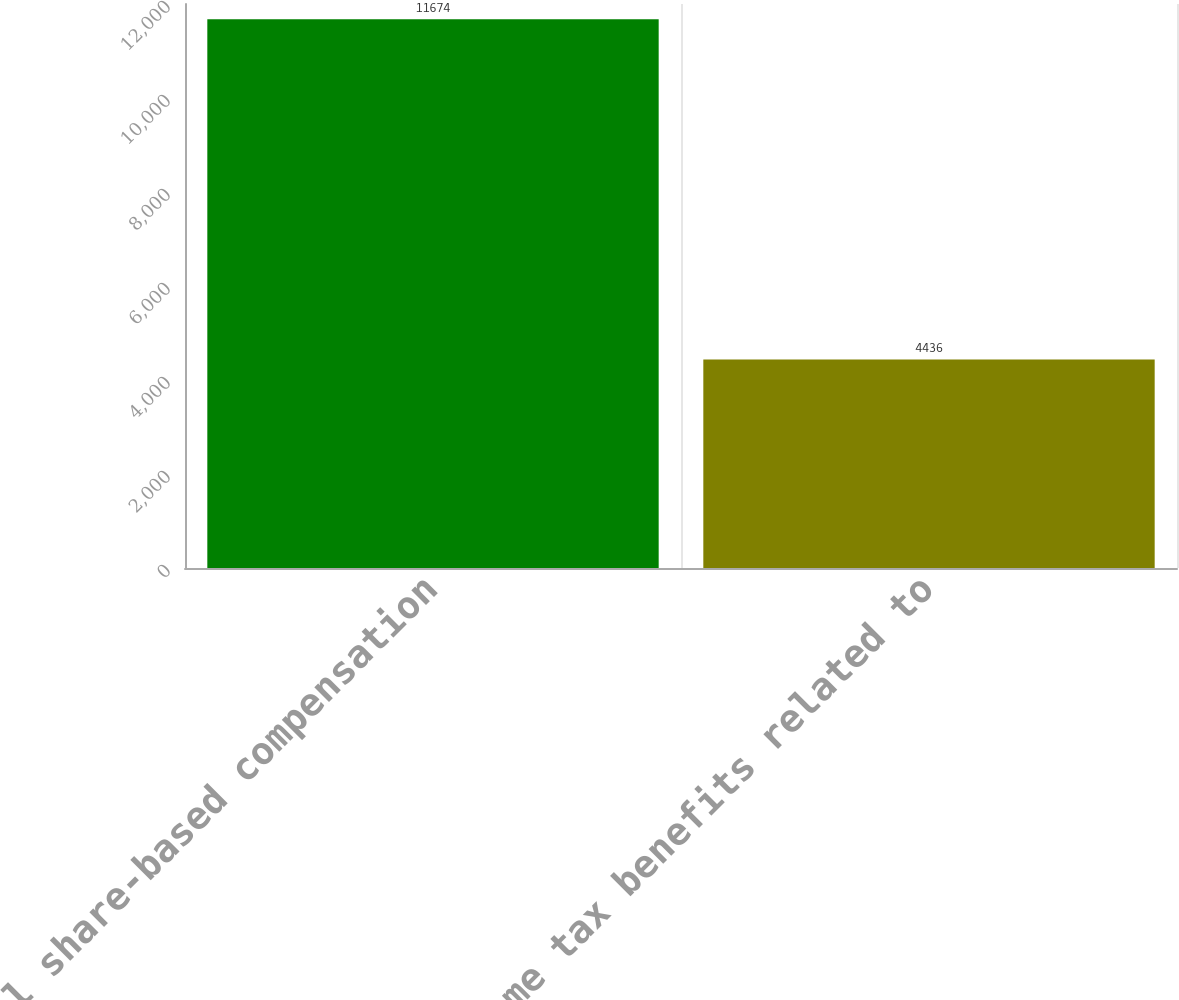Convert chart. <chart><loc_0><loc_0><loc_500><loc_500><bar_chart><fcel>Total share-based compensation<fcel>Income tax benefits related to<nl><fcel>11674<fcel>4436<nl></chart> 